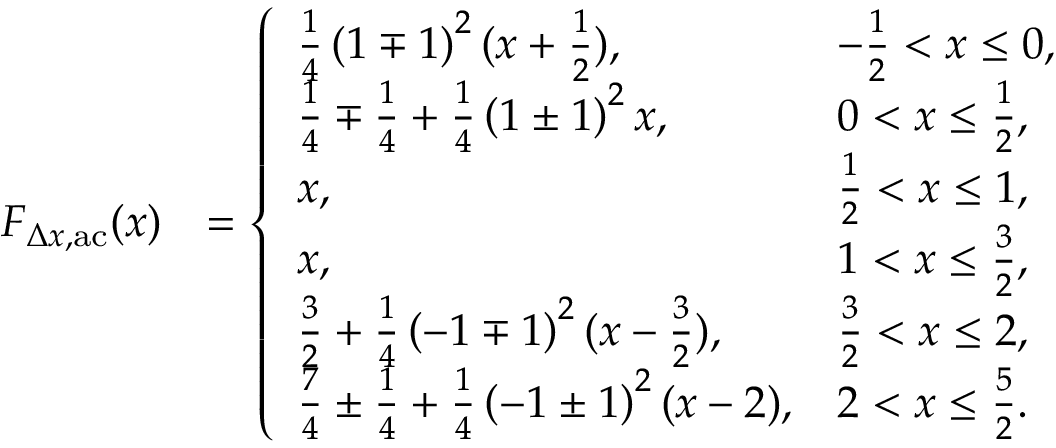Convert formula to latex. <formula><loc_0><loc_0><loc_500><loc_500>\begin{array} { r l } { F _ { \Delta x , a c } ( x ) } & { = \left \{ \begin{array} { l l } { \frac { 1 } { 4 } \left ( 1 \mp 1 \right ) ^ { 2 } ( x + \frac { 1 } { 2 } ) , } & { - \frac { 1 } { 2 } < x \leq 0 , } \\ { \frac { 1 } { 4 } \mp \frac { 1 } { 4 } + \frac { 1 } { 4 } \left ( 1 \pm 1 \right ) ^ { 2 } x , } & { 0 < x \leq \frac { 1 } { 2 } , } \\ { x , } & { \frac { 1 } { 2 } < x \leq 1 , } \\ { x , } & { 1 < x \leq \frac { 3 } { 2 } , } \\ { \frac { 3 } { 2 } + \frac { 1 } { 4 } \left ( - 1 \mp 1 \right ) ^ { 2 } ( x - \frac { 3 } { 2 } ) , } & { \frac { 3 } { 2 } < x \leq 2 , } \\ { \frac { 7 } { 4 } \pm \frac { 1 } { 4 } + \frac { 1 } { 4 } \left ( - 1 \pm 1 \right ) ^ { 2 } ( x - 2 ) , } & { 2 < x \leq \frac { 5 } { 2 } . } \end{array} } \end{array}</formula> 